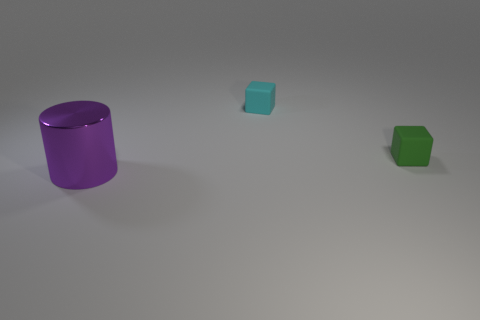Add 1 tiny rubber objects. How many objects exist? 4 Subtract all small green matte spheres. Subtract all tiny cyan rubber things. How many objects are left? 2 Add 1 tiny cyan matte blocks. How many tiny cyan matte blocks are left? 2 Add 2 metal things. How many metal things exist? 3 Subtract 1 purple cylinders. How many objects are left? 2 Subtract all cylinders. How many objects are left? 2 